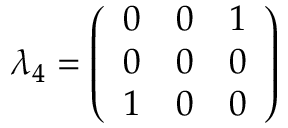Convert formula to latex. <formula><loc_0><loc_0><loc_500><loc_500>\lambda _ { 4 } = { \left ( \begin{array} { l l l } { 0 } & { 0 } & { 1 } \\ { 0 } & { 0 } & { 0 } \\ { 1 } & { 0 } & { 0 } \end{array} \right ) }</formula> 